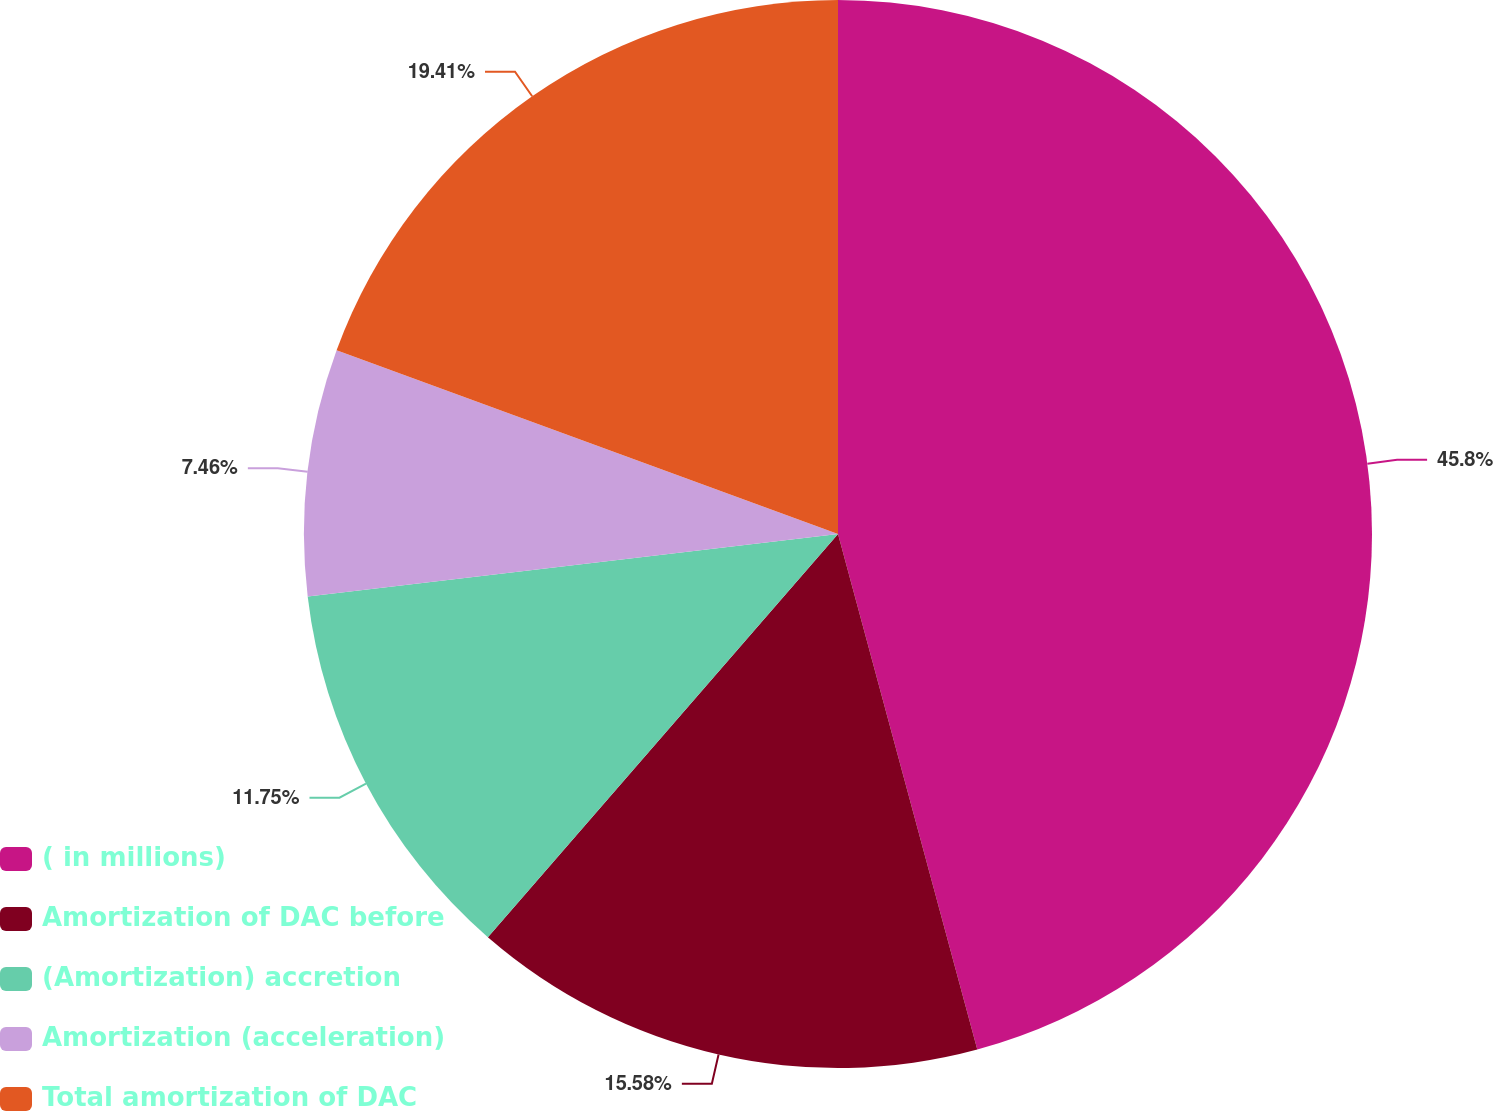Convert chart to OTSL. <chart><loc_0><loc_0><loc_500><loc_500><pie_chart><fcel>( in millions)<fcel>Amortization of DAC before<fcel>(Amortization) accretion<fcel>Amortization (acceleration)<fcel>Total amortization of DAC<nl><fcel>45.8%<fcel>15.58%<fcel>11.75%<fcel>7.46%<fcel>19.41%<nl></chart> 